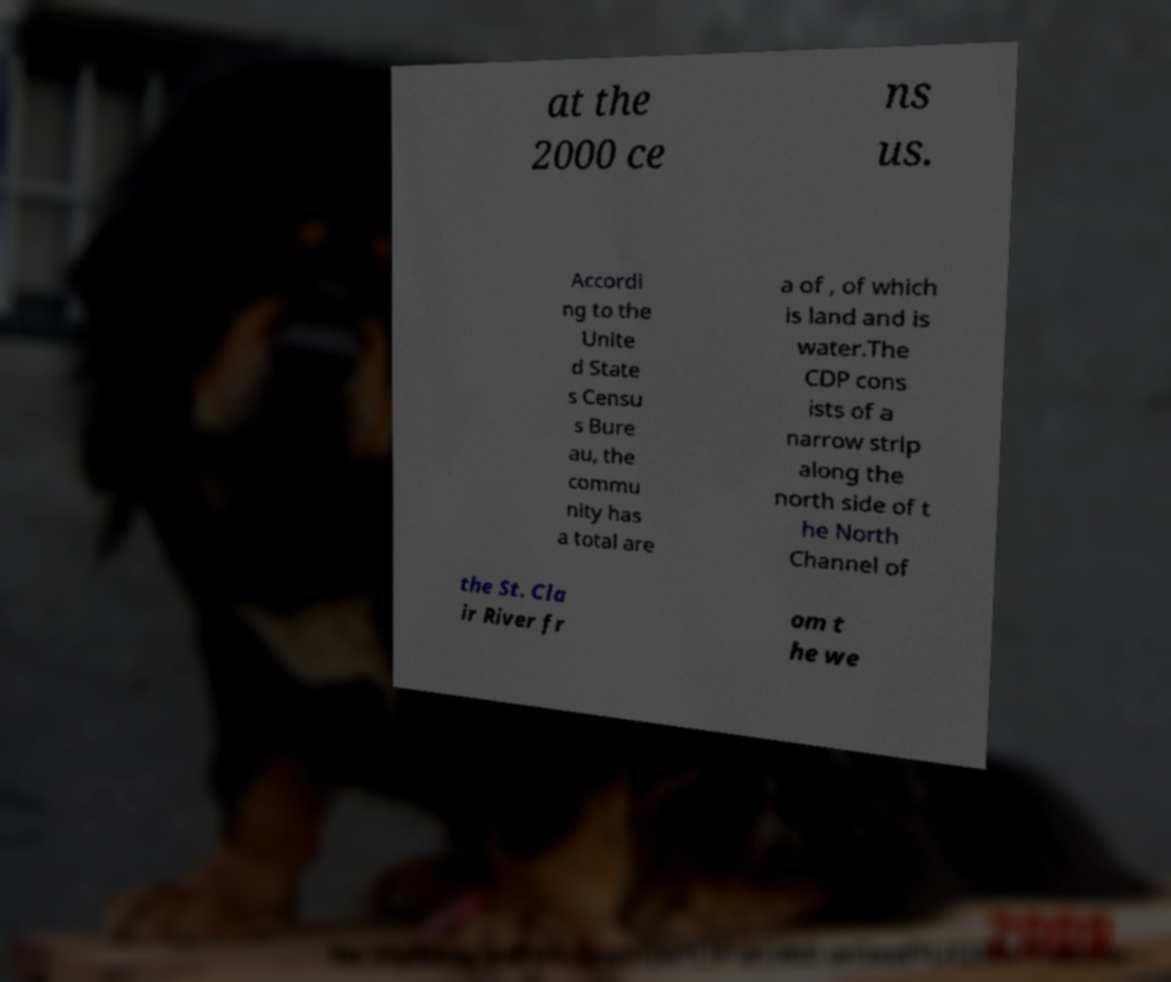Please identify and transcribe the text found in this image. at the 2000 ce ns us. Accordi ng to the Unite d State s Censu s Bure au, the commu nity has a total are a of , of which is land and is water.The CDP cons ists of a narrow strip along the north side of t he North Channel of the St. Cla ir River fr om t he we 